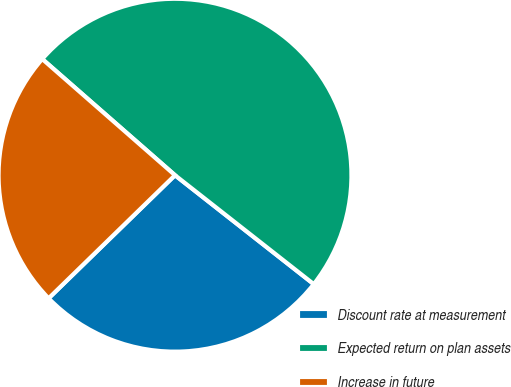Convert chart to OTSL. <chart><loc_0><loc_0><loc_500><loc_500><pie_chart><fcel>Discount rate at measurement<fcel>Expected return on plan assets<fcel>Increase in future<nl><fcel>27.12%<fcel>49.15%<fcel>23.73%<nl></chart> 